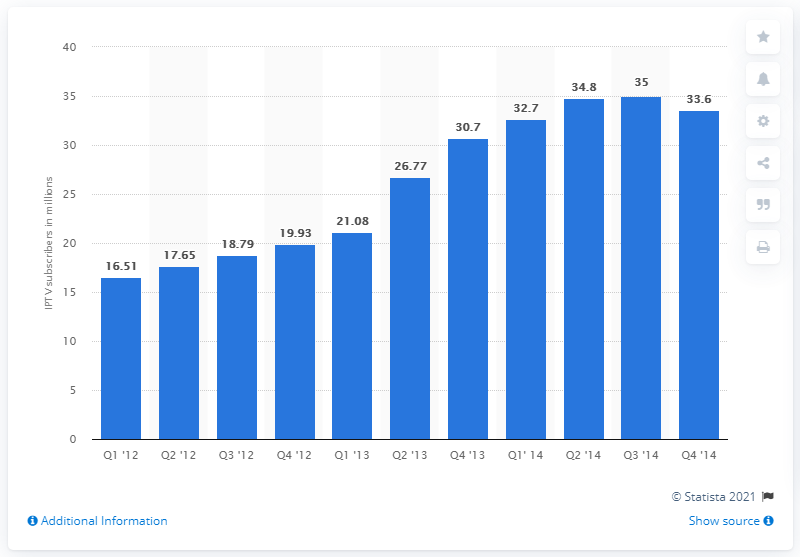Indicate a few pertinent items in this graphic. In the fourth quarter of 2013, there were 30.7 million IPTV subscribers in China. 